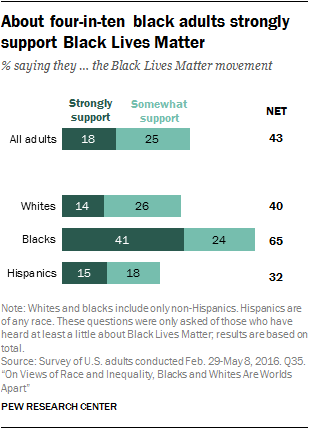List a handful of essential elements in this visual. The number of groups with net support rates over 40% is 2. 